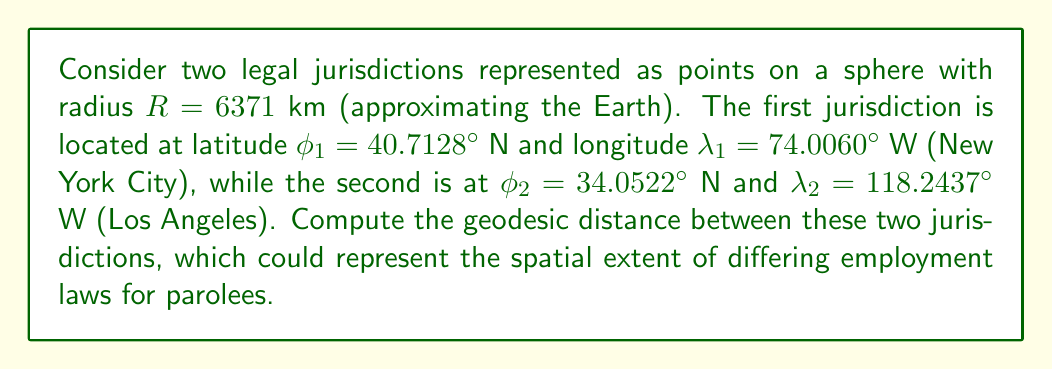Help me with this question. To solve this problem, we'll use the Haversine formula, which calculates the great-circle distance between two points on a sphere. This is particularly relevant when considering the geographic scope of differing legal jurisdictions.

Step 1: Convert latitudes and longitudes from degrees to radians.
$$\phi_1 = 40.7128° \times \frac{\pi}{180} = 0.7105 \text{ rad}$$
$$\lambda_1 = -74.0060° \times \frac{\pi}{180} = -1.2915 \text{ rad}$$
$$\phi_2 = 34.0522° \times \frac{\pi}{180} = 0.5942 \text{ rad}$$
$$\lambda_2 = -118.2437° \times \frac{\pi}{180} = -2.0638 \text{ rad}$$

Step 2: Calculate the difference in longitudes.
$$\Delta\lambda = \lambda_2 - \lambda_1 = -2.0638 - (-1.2915) = -0.7723 \text{ rad}$$

Step 3: Apply the Haversine formula:
$$a = \sin^2\left(\frac{\phi_2 - \phi_1}{2}\right) + \cos(\phi_1)\cos(\phi_2)\sin^2\left(\frac{\Delta\lambda}{2}\right)$$

$$a = \sin^2\left(\frac{0.5942 - 0.7105}{2}\right) + \cos(0.7105)\cos(0.5942)\sin^2\left(\frac{-0.7723}{2}\right) = 0.1974$$

Step 4: Calculate the central angle:
$$c = 2 \times \arctan2(\sqrt{a}, \sqrt{1-a}) = 0.9229 \text{ rad}$$

Step 5: Compute the geodesic distance:
$$d = R \times c = 6371 \times 0.9229 = 5878.5 \text{ km}$$

This distance represents the shortest path between the two jurisdictions along the Earth's surface, which is crucial when considering the spatial extent of differing employment laws for parolees.
Answer: 5878.5 km 